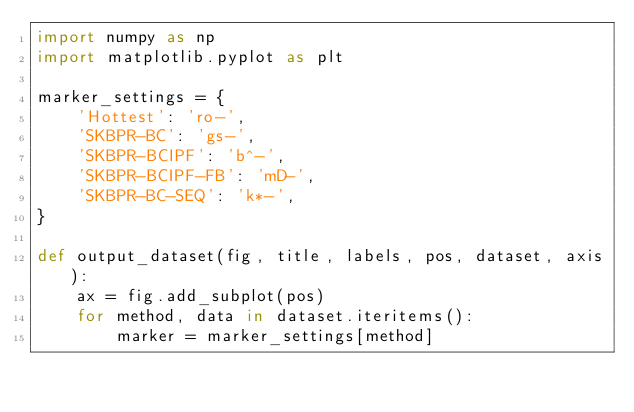<code> <loc_0><loc_0><loc_500><loc_500><_Python_>import numpy as np
import matplotlib.pyplot as plt

marker_settings = {
    'Hottest': 'ro-',
    'SKBPR-BC': 'gs-',
    'SKBPR-BCIPF': 'b^-',
    'SKBPR-BCIPF-FB': 'mD-',
    'SKBPR-BC-SEQ': 'k*-',
}

def output_dataset(fig, title, labels, pos, dataset, axis):
    ax = fig.add_subplot(pos)
    for method, data in dataset.iteritems():
        marker = marker_settings[method]</code> 